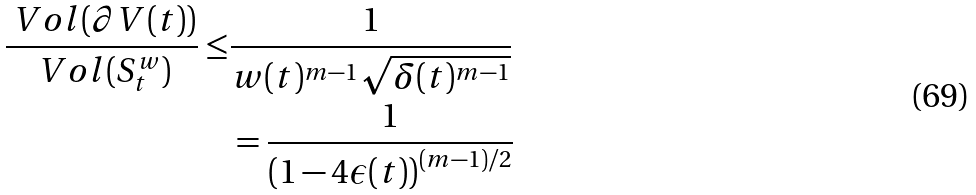<formula> <loc_0><loc_0><loc_500><loc_500>\frac { \ V o l ( \partial V ( t ) ) } { \ V o l ( S _ { t } ^ { w } ) } \leq & \frac { 1 } { w ( t ) ^ { m - 1 } \sqrt { \delta ( t ) ^ { m - 1 } } } \\ & = \frac { 1 } { \left ( 1 - 4 \epsilon ( t ) \right ) ^ { ( m - 1 ) / 2 } }</formula> 